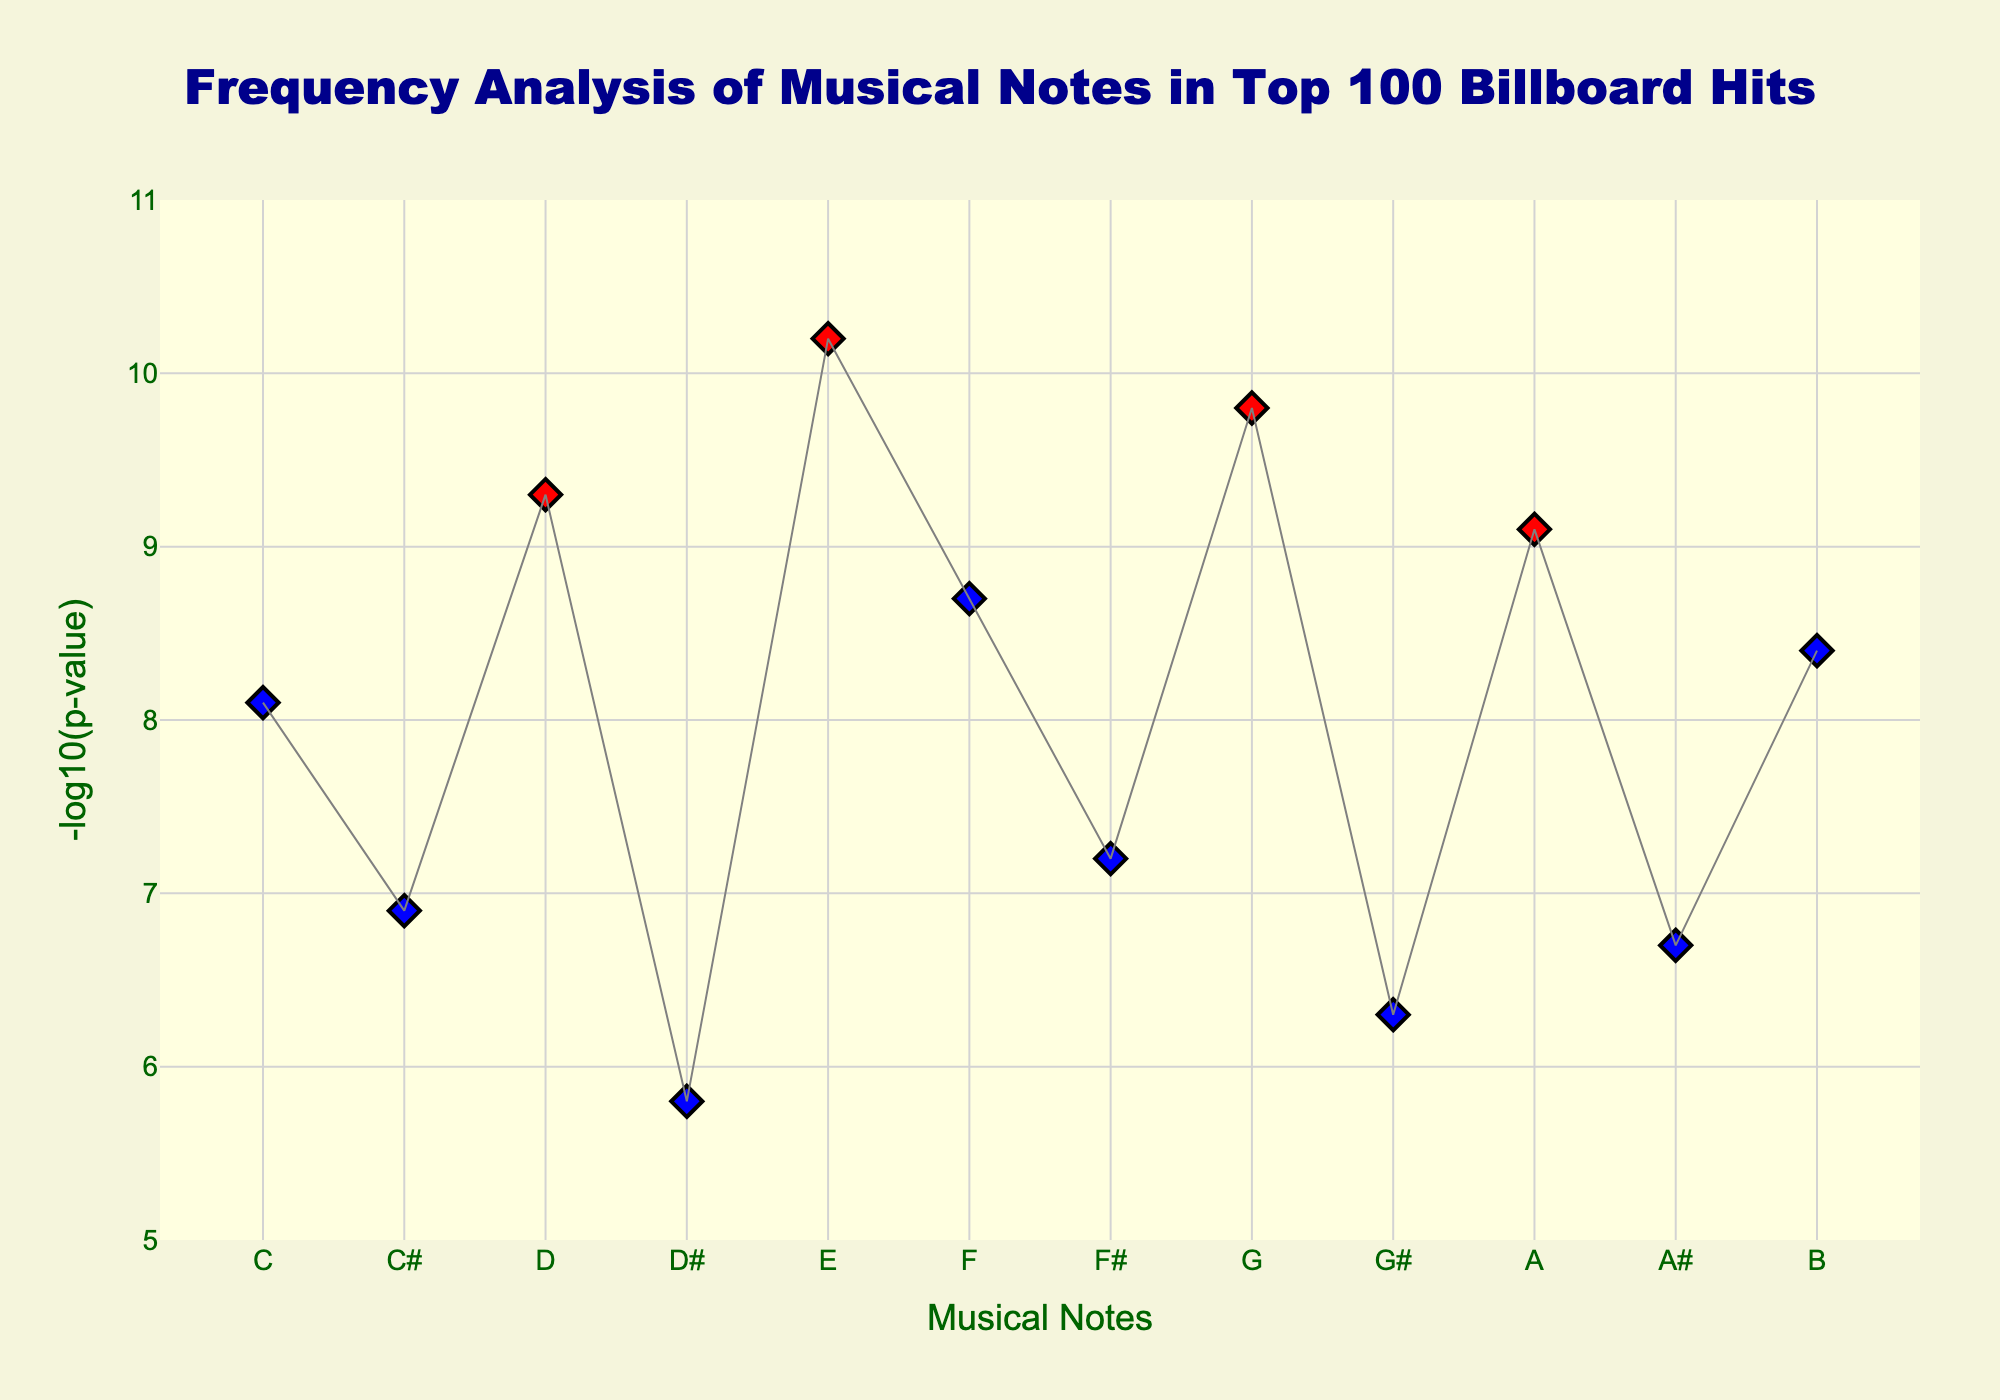What is the title of the plot? The title is normally found at the top of the plot and generally explains what the plot represents. In this case, the title is displayed prominently in a large font.
Answer: Frequency Analysis of Musical Notes in Top 100 Billboard Hits What does the y-axis represent? The y-axis label is present on the left side of the plot, which shows the measure that is being plotted against the x-axis. It is titled '-log10(p-value)'.
Answer: -log10(p-value) Which note has the highest -log10(p-value)? Look at the y-values for each note and find the one that is the highest. The corresponding note for this y-value will be the answer.
Answer: E Which notes have a -log10(p-value) greater than 9? Identify all the data points where the y-value exceeds 9. The notes corresponding to these points are the ones we are interested in. We see that the notes D, E, G, and A have -log10(p-values) greater than 9.
Answer: D, E, G, A How many notes have -log10(p-values) above 9? Count the number of data points where the y-value is greater than 9. These points are easily identifiable by their red color in the plot. There are 4 such points.
Answer: 4 Which note has the lowest -log10(p-value)? Examine the plot and find the data point that is closest to the bottom (lowest on the y-axis). The note corresponding to this data point is our answer.
Answer: D# How does the -log10(p-value) of note B compare to note D#? Find the y-values of notes B and D# on the plot and compare them directly. Note B has a higher -log10(p-value) than note D#.
Answer: Higher By how much is the -log10(p-value) for note E higher than note F#? Subtract the -log10(p-value) of note F# from that of note E to find the difference. Calculation: 10.2 - 7.2 = 3.0.
Answer: 3.0 Which note is used more frequently based on -log10(p-value), A# or G#? Compare the -log10(p-values) of notes A# and G#. The note with the higher value is used more frequently. Note A# has a higher -log10(p-value) than G#.
Answer: A# Are there any notes with the same -log10(p-value)? Check if any y-values are repeated in the plot. In this case, no two notes share the same -log10(p-value); each is unique.
Answer: No 